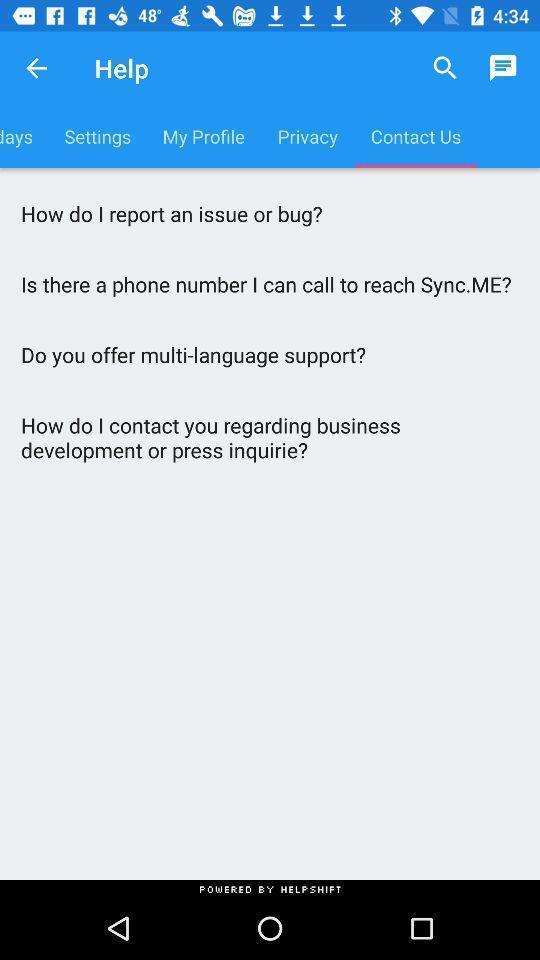What is the overall content of this screenshot? Screen showing help page. 